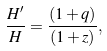<formula> <loc_0><loc_0><loc_500><loc_500>\frac { H ^ { \prime } } { H } = \frac { ( 1 + q ) } { ( 1 + z ) } ,</formula> 